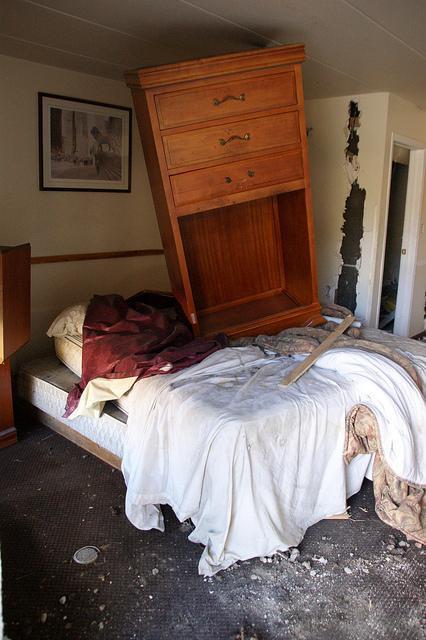How many people use this bed?
Give a very brief answer. 2. 